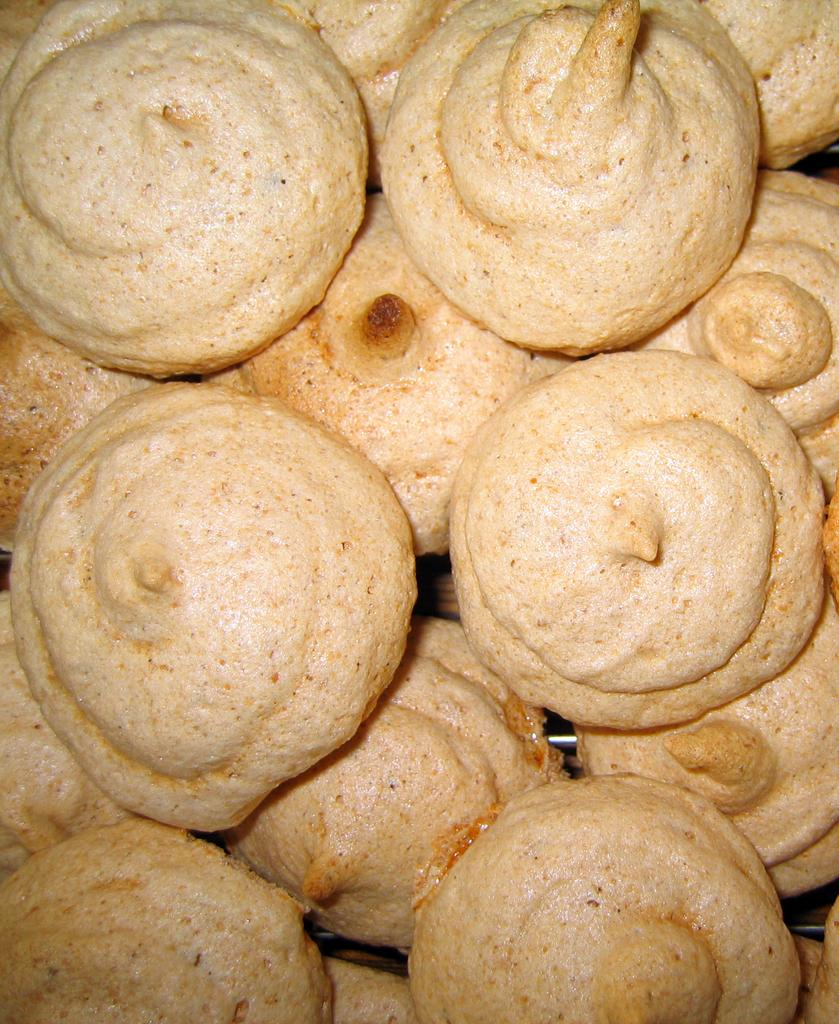What can be seen in the image? There are food items in the image. Where are the food items located? The food items are on an object. Can you hear the moon crying in the image? There is no moon or any indication of crying in the image; it only features food items on an object. 